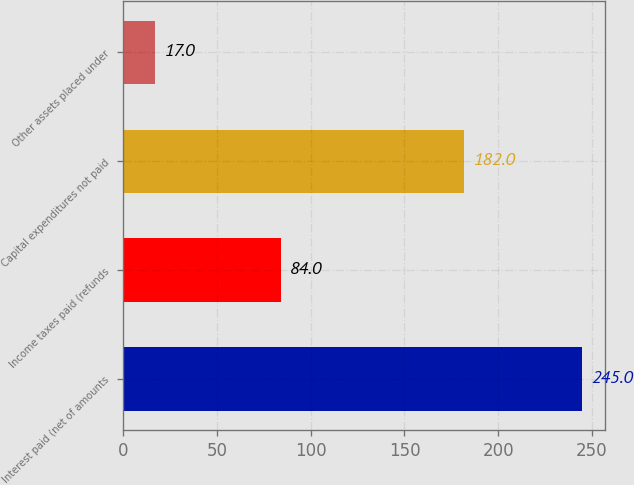Convert chart to OTSL. <chart><loc_0><loc_0><loc_500><loc_500><bar_chart><fcel>Interest paid (net of amounts<fcel>Income taxes paid (refunds<fcel>Capital expenditures not paid<fcel>Other assets placed under<nl><fcel>245<fcel>84<fcel>182<fcel>17<nl></chart> 